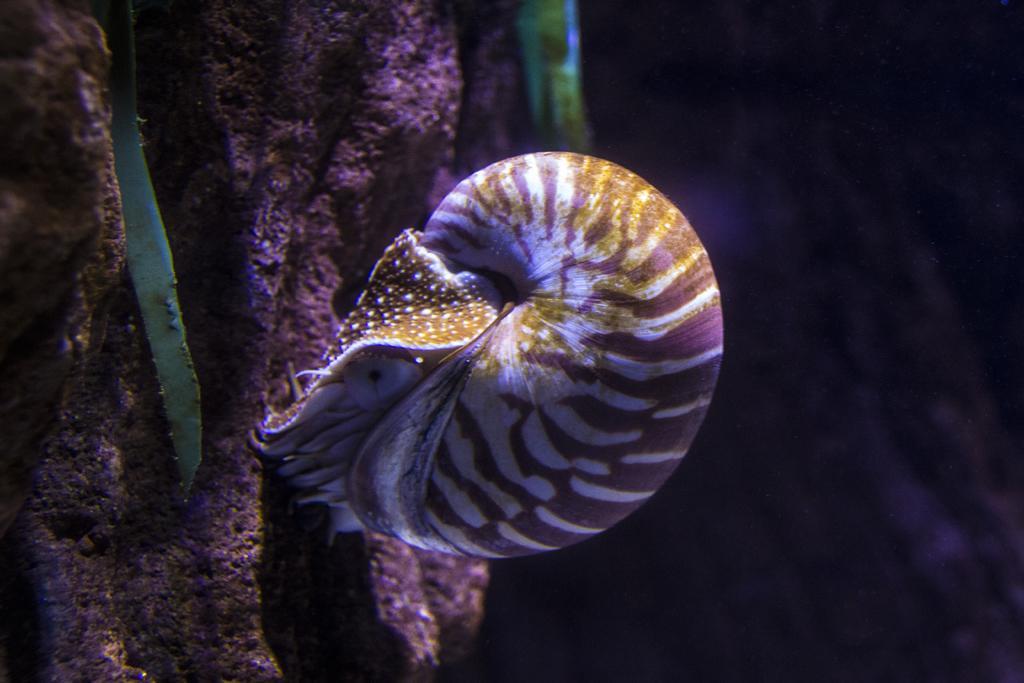In one or two sentences, can you explain what this image depicts? In this image there is a Chambered nautilus in the water, in front of it there is a tree. 